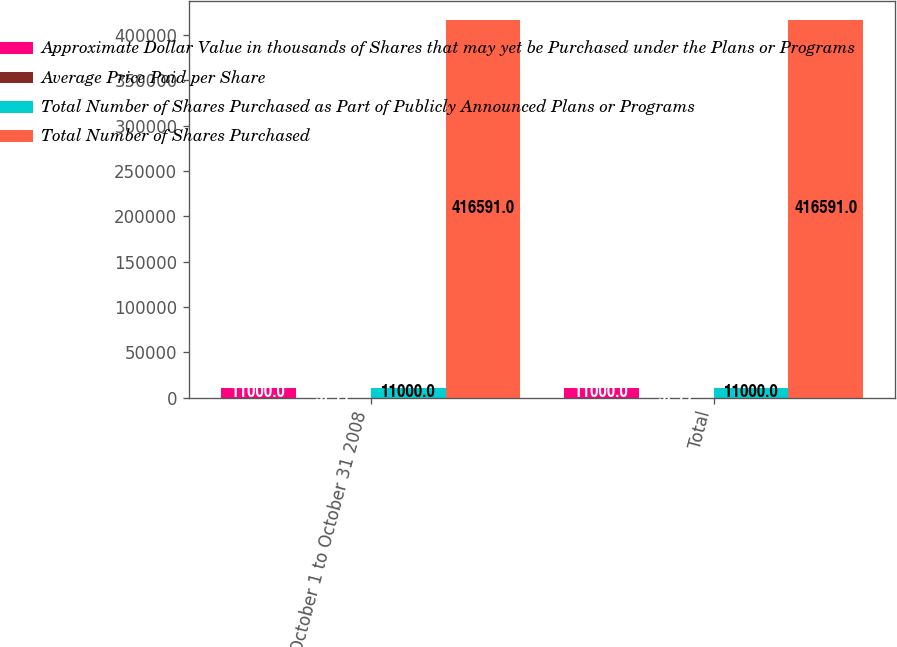Convert chart to OTSL. <chart><loc_0><loc_0><loc_500><loc_500><stacked_bar_chart><ecel><fcel>October 1 to October 31 2008<fcel>Total<nl><fcel>Approximate Dollar Value in thousands of Shares that may yet be Purchased under the Plans or Programs<fcel>11000<fcel>11000<nl><fcel>Average Price Paid per Share<fcel>97.77<fcel>97.77<nl><fcel>Total Number of Shares Purchased as Part of Publicly Announced Plans or Programs<fcel>11000<fcel>11000<nl><fcel>Total Number of Shares Purchased<fcel>416591<fcel>416591<nl></chart> 